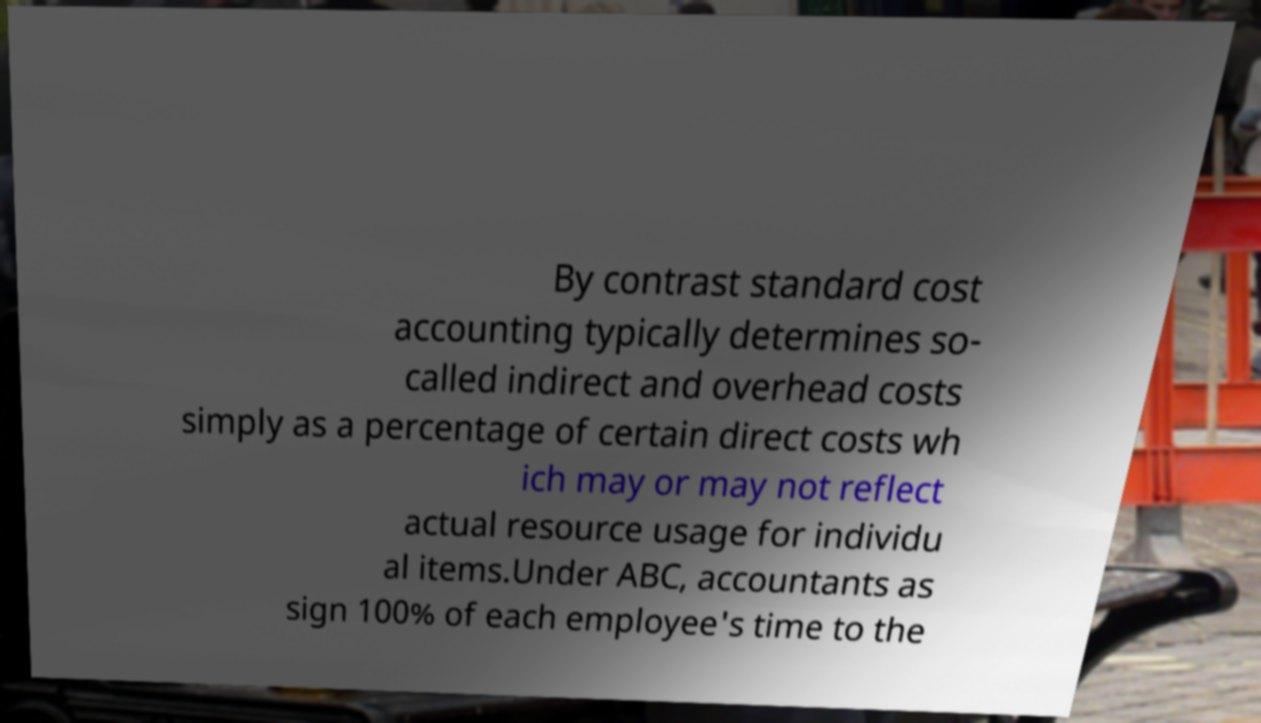What messages or text are displayed in this image? I need them in a readable, typed format. By contrast standard cost accounting typically determines so- called indirect and overhead costs simply as a percentage of certain direct costs wh ich may or may not reflect actual resource usage for individu al items.Under ABC, accountants as sign 100% of each employee's time to the 